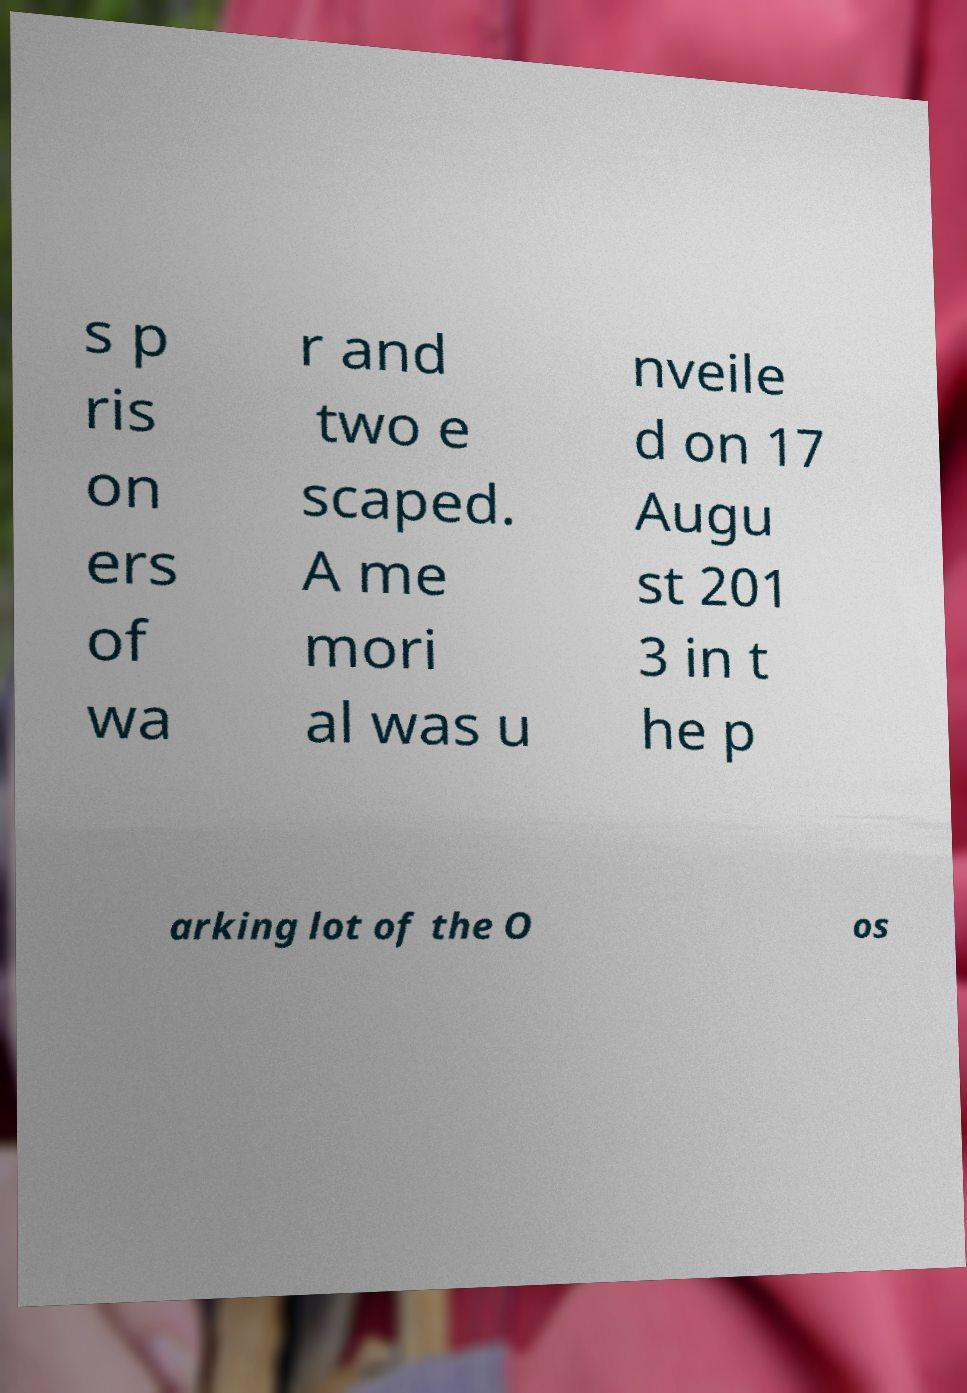I need the written content from this picture converted into text. Can you do that? s p ris on ers of wa r and two e scaped. A me mori al was u nveile d on 17 Augu st 201 3 in t he p arking lot of the O os 